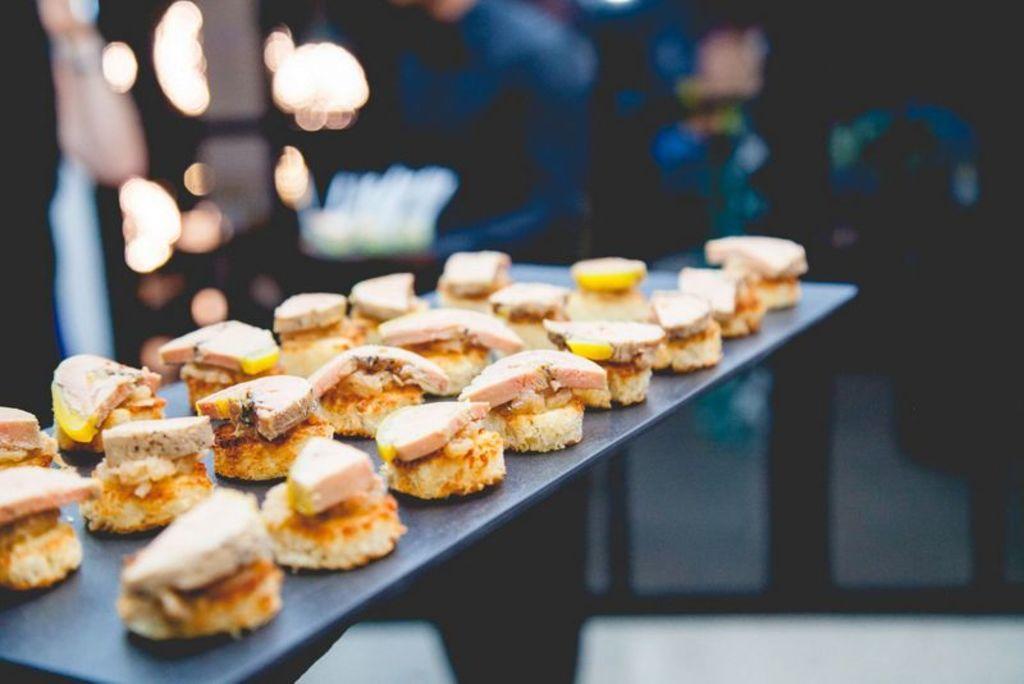Can you describe this image briefly? In this image there is a person's standing, there is a table towards the bottom of the image, there is food on the table, there is a glass wall, there are lights, the background of the image is blurred. 